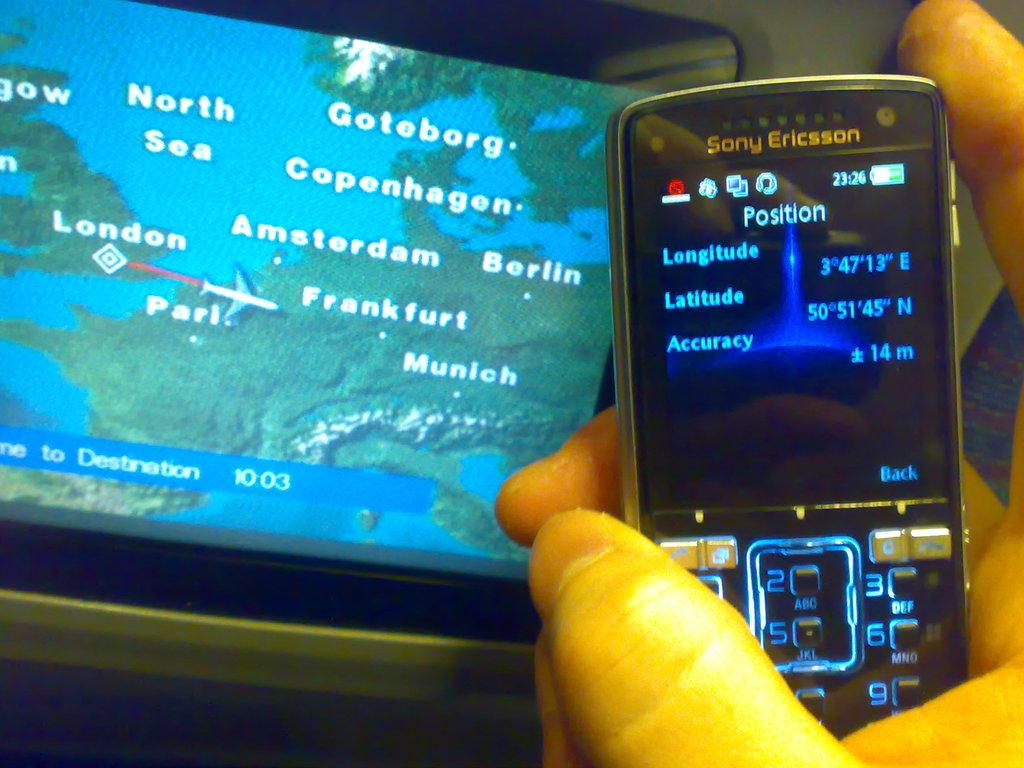Provide a one-sentence caption for the provided image. A phone in front of a screen on a seat back showing a map of Europe with countries labeled. 